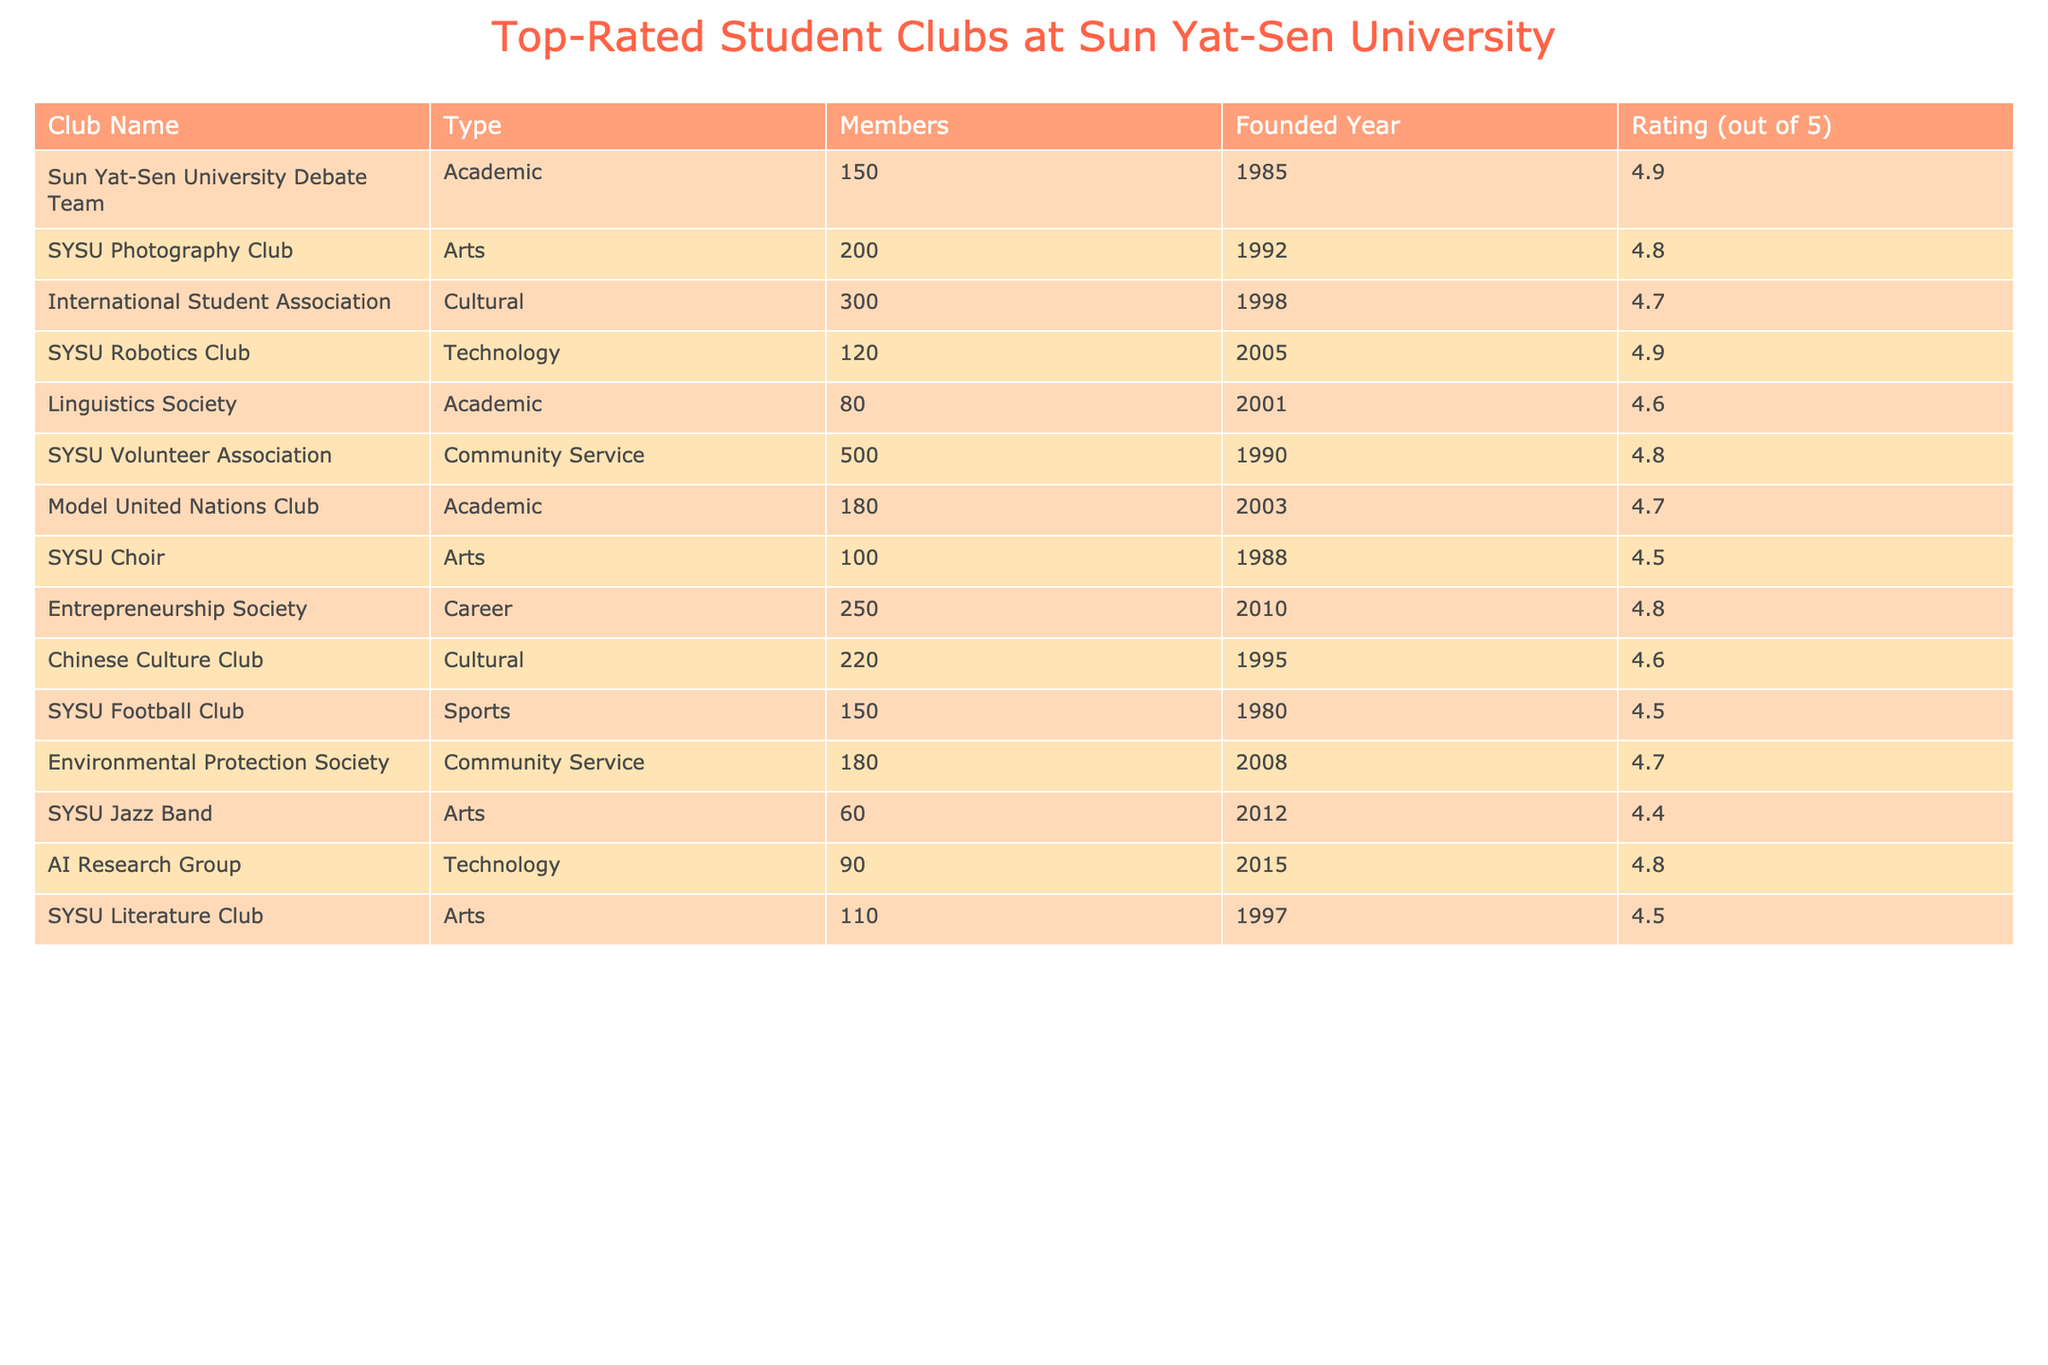What is the highest rating achieved by a student club at Sun Yat-Sen University? The highest rating listed in the table is 4.9, which is achieved by two clubs: the Sun Yat-Sen University Debate Team and the SYSU Robotics Club.
Answer: 4.9 How many members are in the SYSU Volunteer Association? The table shows that the SYSU Volunteer Association has 500 members.
Answer: 500 Which club was founded most recently? The AI Research Group is the most recently founded club in 2015, according to the Founded Year column.
Answer: AI Research Group What is the average rating of the Arts clubs listed? The Arts clubs are SYSU Photography Club, SYSU Choir, SYSU Jazz Band, and SYSU Literature Club, with ratings of 4.8, 4.5, 4.4, and 4.5 respectively. The average is (4.8 + 4.5 + 4.4 + 4.5) / 4 = 4.55.
Answer: 4.55 Is the International Student Association the largest club by membership? The International Student Association has 300 members, but the SYSU Volunteer Association has 500 members, so it is not the largest.
Answer: No How many clubs have a rating of 4.7 or higher? The clubs with a rating of 4.7 or higher include the SUN Yat-Sen University Debate Team, SYSU Robotics Club, International Student Association, Model United Nations Club, Entrepreneurship Society, AI Research Group, and Environmental Protection Society. Counting these gives a total of 7 clubs.
Answer: 7 What is the difference in the number of members between the SYSU Choir and the SYSU Photography Club? The SYSU Choir has 100 members and the SYSU Photography Club has 200 members. The difference is 200 - 100 = 100.
Answer: 100 Which type of club has the most clubs listed in this table? By reviewing the table, the Academic type has four clubs: Sun Yat-Sen University Debate Team, Linguistics Society, Model United Nations Club, and thus is the type with the most clubs.
Answer: Academic What is the total number of members in the Technology clubs? The Technology clubs are the SYSU Robotics Club and the AI Research Group, which have 120 and 90 members respectively. The total is 120 + 90 = 210.
Answer: 210 Do any club ratings equal the average rating of all clubs? The average rating can be calculated: (4.9 + 4.8 + 4.7 + 4.9 + 4.6 + 4.8 + 4.7 + 4.5 + 4.8 + 4.6 + 4.5 + 4.4 + 4.5) / 13 = approximately 4.634. This is not equal to any specific club rating listed.
Answer: No 